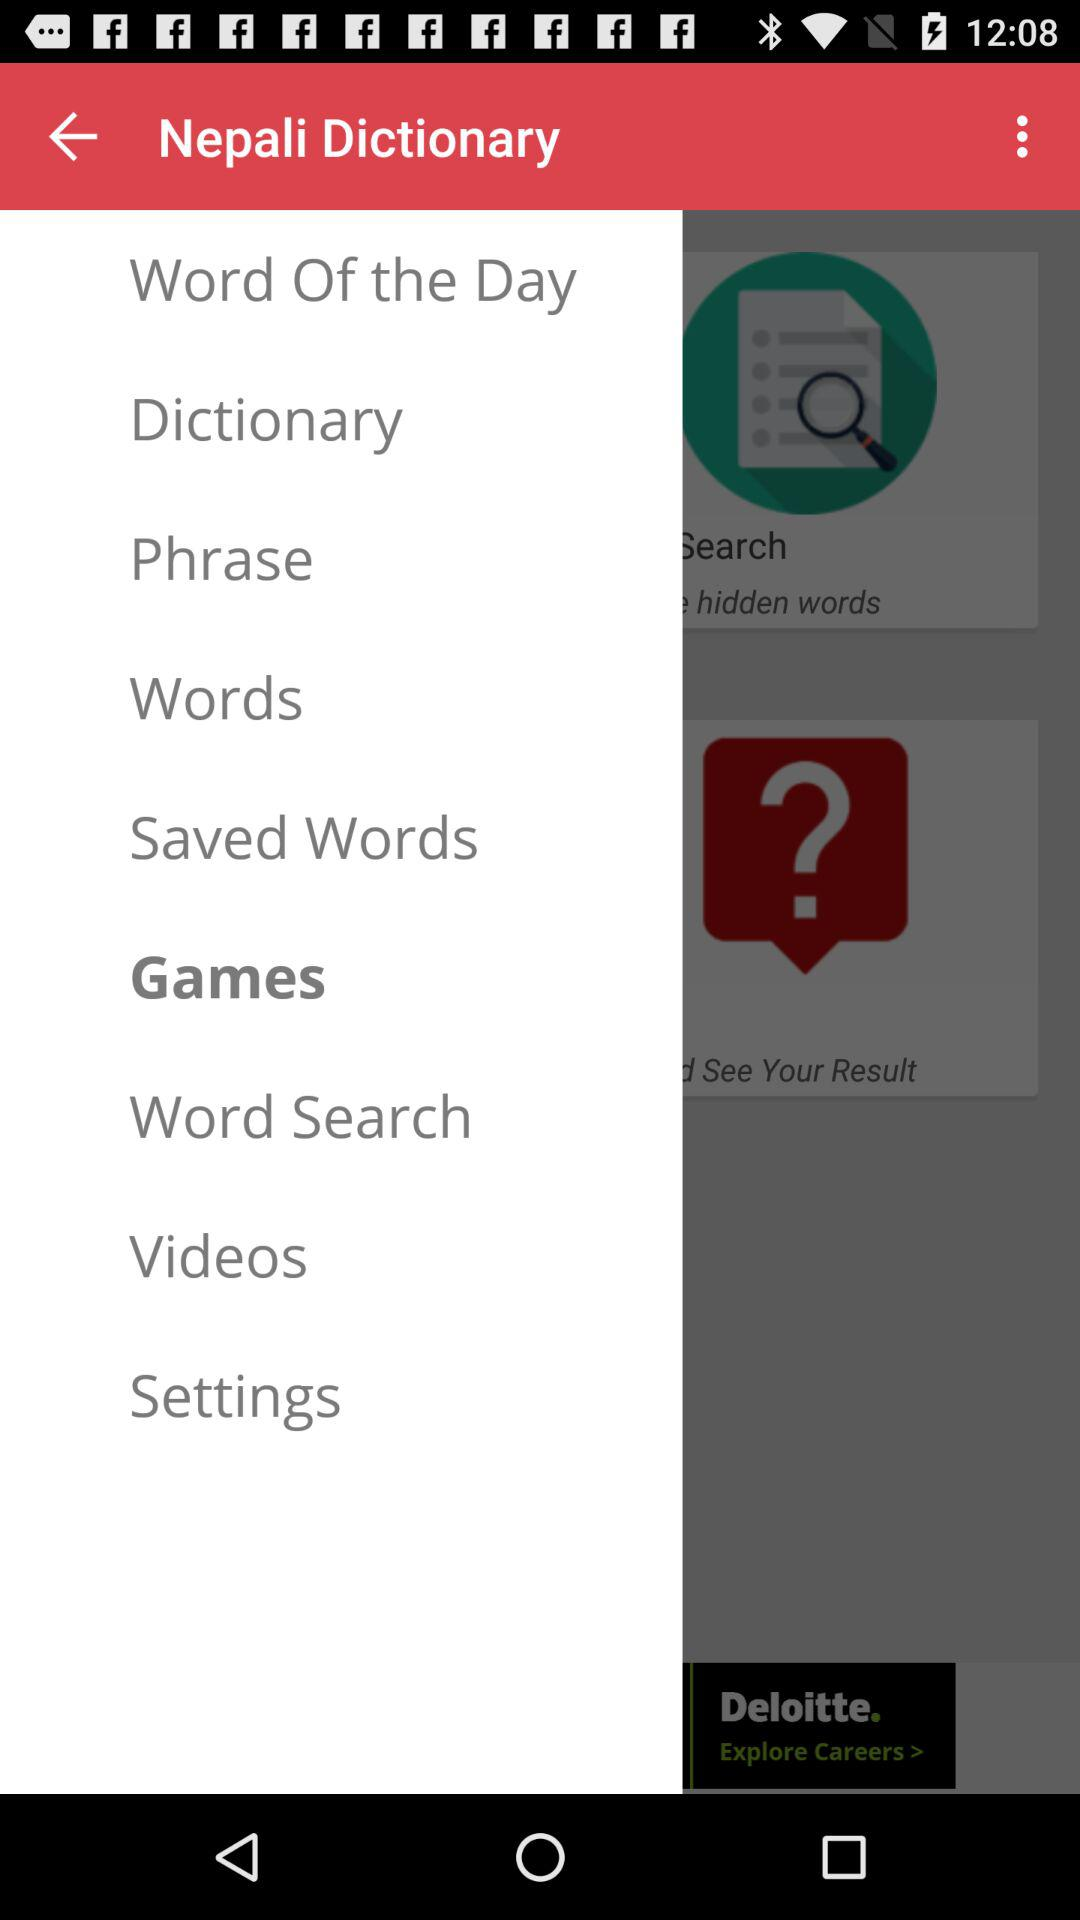What is the application name? The application name is "Nepali Dictionary". 